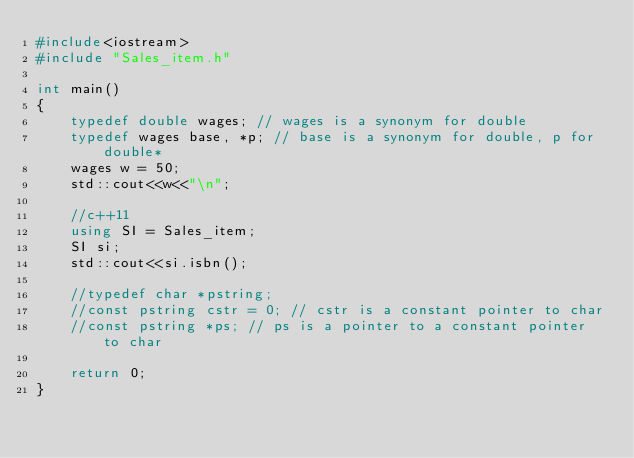<code> <loc_0><loc_0><loc_500><loc_500><_C++_>#include<iostream>
#include "Sales_item.h"

int main()
{
    typedef double wages; // wages is a synonym for double
    typedef wages base, *p; // base is a synonym for double, p for double*
    wages w = 50;
    std::cout<<w<<"\n";
    
    //c++11
    using SI = Sales_item;
    SI si;
    std::cout<<si.isbn();

    //typedef char *pstring;
    //const pstring cstr = 0; // cstr is a constant pointer to char
    //const pstring *ps; // ps is a pointer to a constant pointer to char

    return 0;
}</code> 